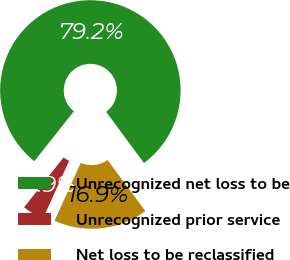Convert chart to OTSL. <chart><loc_0><loc_0><loc_500><loc_500><pie_chart><fcel>Unrecognized net loss to be<fcel>Unrecognized prior service<fcel>Net loss to be reclassified<nl><fcel>79.22%<fcel>3.9%<fcel>16.88%<nl></chart> 